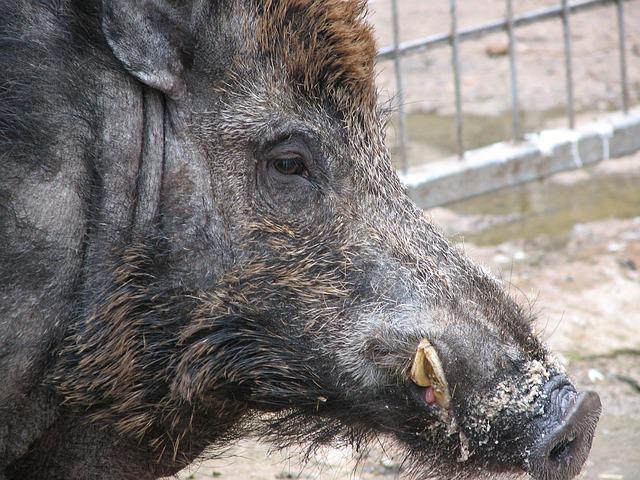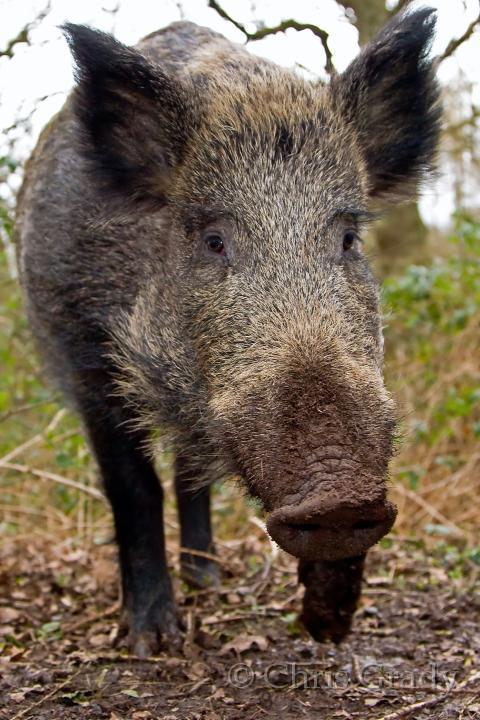The first image is the image on the left, the second image is the image on the right. Evaluate the accuracy of this statement regarding the images: "There are exactly two boars, and they don't look like the same boar.". Is it true? Answer yes or no. Yes. 